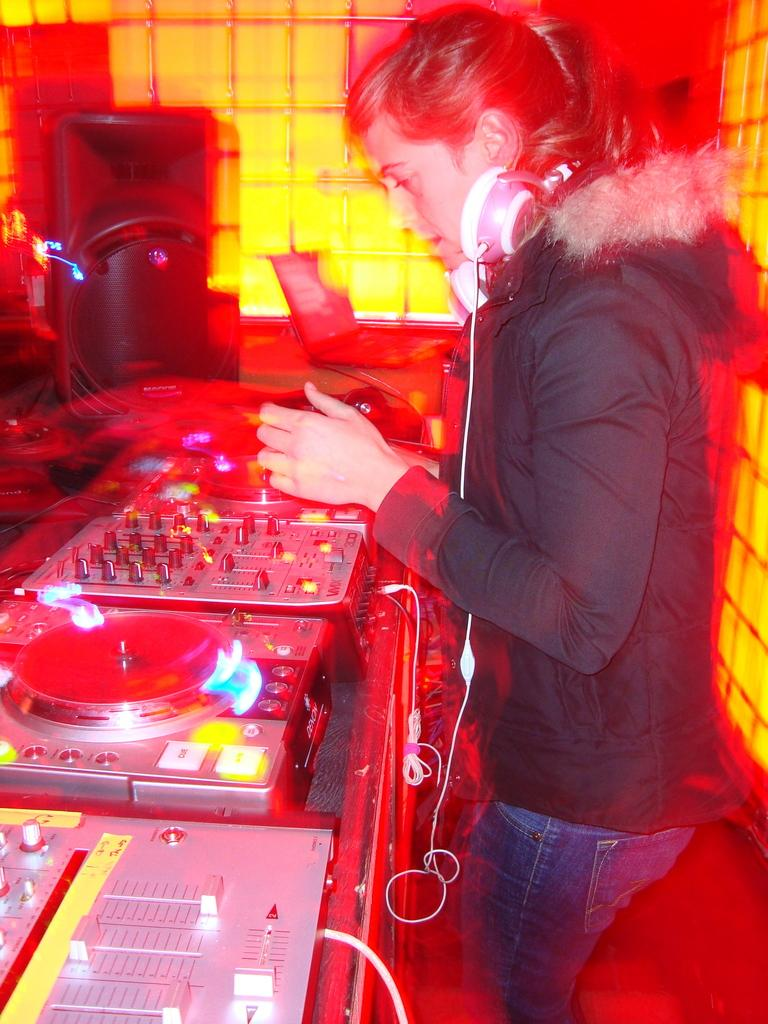What can be seen in the image? There is a person in the image. What is the person wearing? The person is wearing a black jacket and jeans. What is the person holding in the image? The person is wearing a headset. What is the person standing in front of? The person is standing in front of musical instruments. How is the background of the image? The background of the image is blurred. What type of seed is the person planting in the image? There is no seed or planting activity present in the image. What tool is the person using to fix the mailbox in the image? There is no mailbox or tool present in the image. 